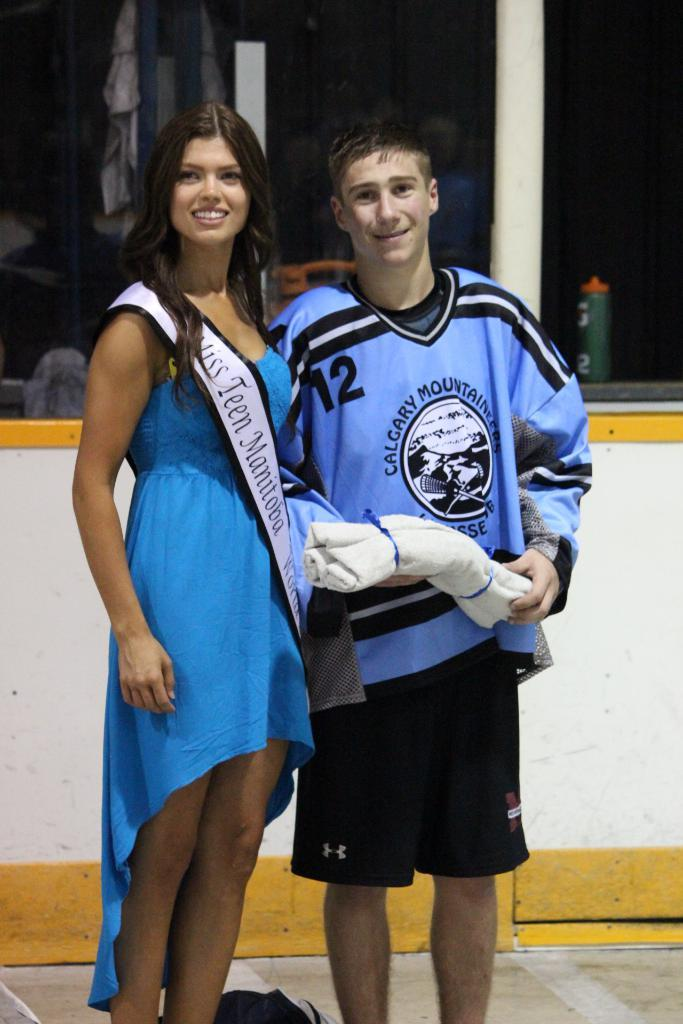<image>
Present a compact description of the photo's key features. Miss Teen Manitoba poses with a hockey player in blue jersey. 